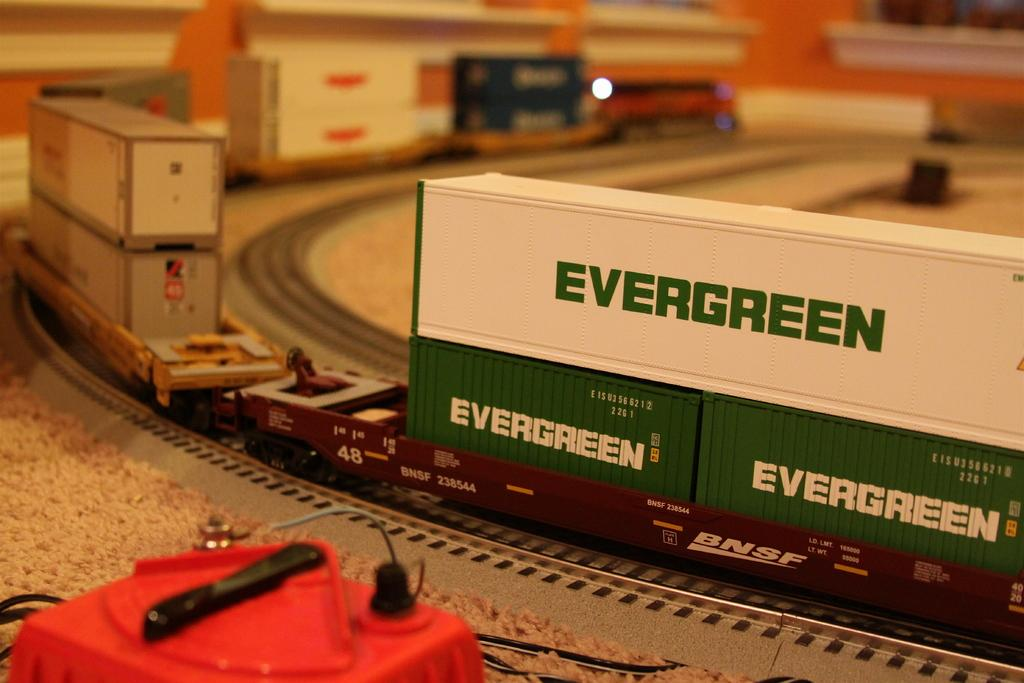<image>
Describe the image concisely. an evergreen item that is on a track 